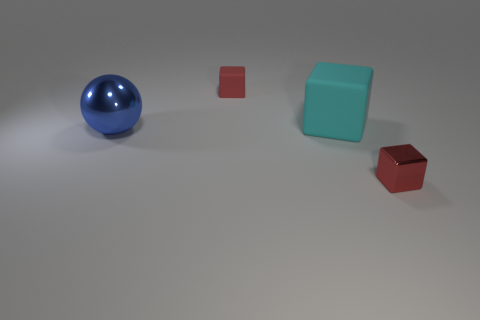Subtract all matte blocks. How many blocks are left? 1 Add 2 small yellow metallic blocks. How many objects exist? 6 Subtract all cyan cubes. How many cubes are left? 2 Subtract all spheres. How many objects are left? 3 Subtract 1 balls. How many balls are left? 0 Subtract all brown blocks. Subtract all yellow balls. How many blocks are left? 3 Subtract all brown blocks. How many gray balls are left? 0 Subtract all small cyan shiny balls. Subtract all cyan rubber cubes. How many objects are left? 3 Add 1 tiny objects. How many tiny objects are left? 3 Add 1 large cyan blocks. How many large cyan blocks exist? 2 